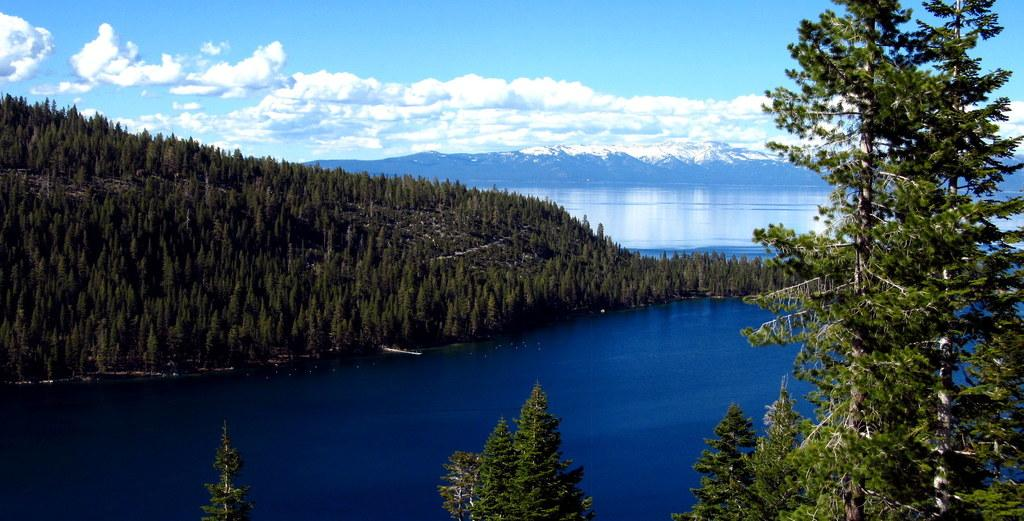What type of vegetation is present in the image? There are many trees in the image. What is located at the bottom of the image? There is water at the bottom of the image. What can be seen in the background of the image? There are mountains in the background of the image. What is the condition of the mountains? The mountains have snow on them. What is visible in the sky at the top of the image? There are clouds in the sky at the top of the image. What color is the committee's scarf in the image? There is no committee or scarf present in the image. How many bottles are visible in the image? There are no bottles present in the image. 